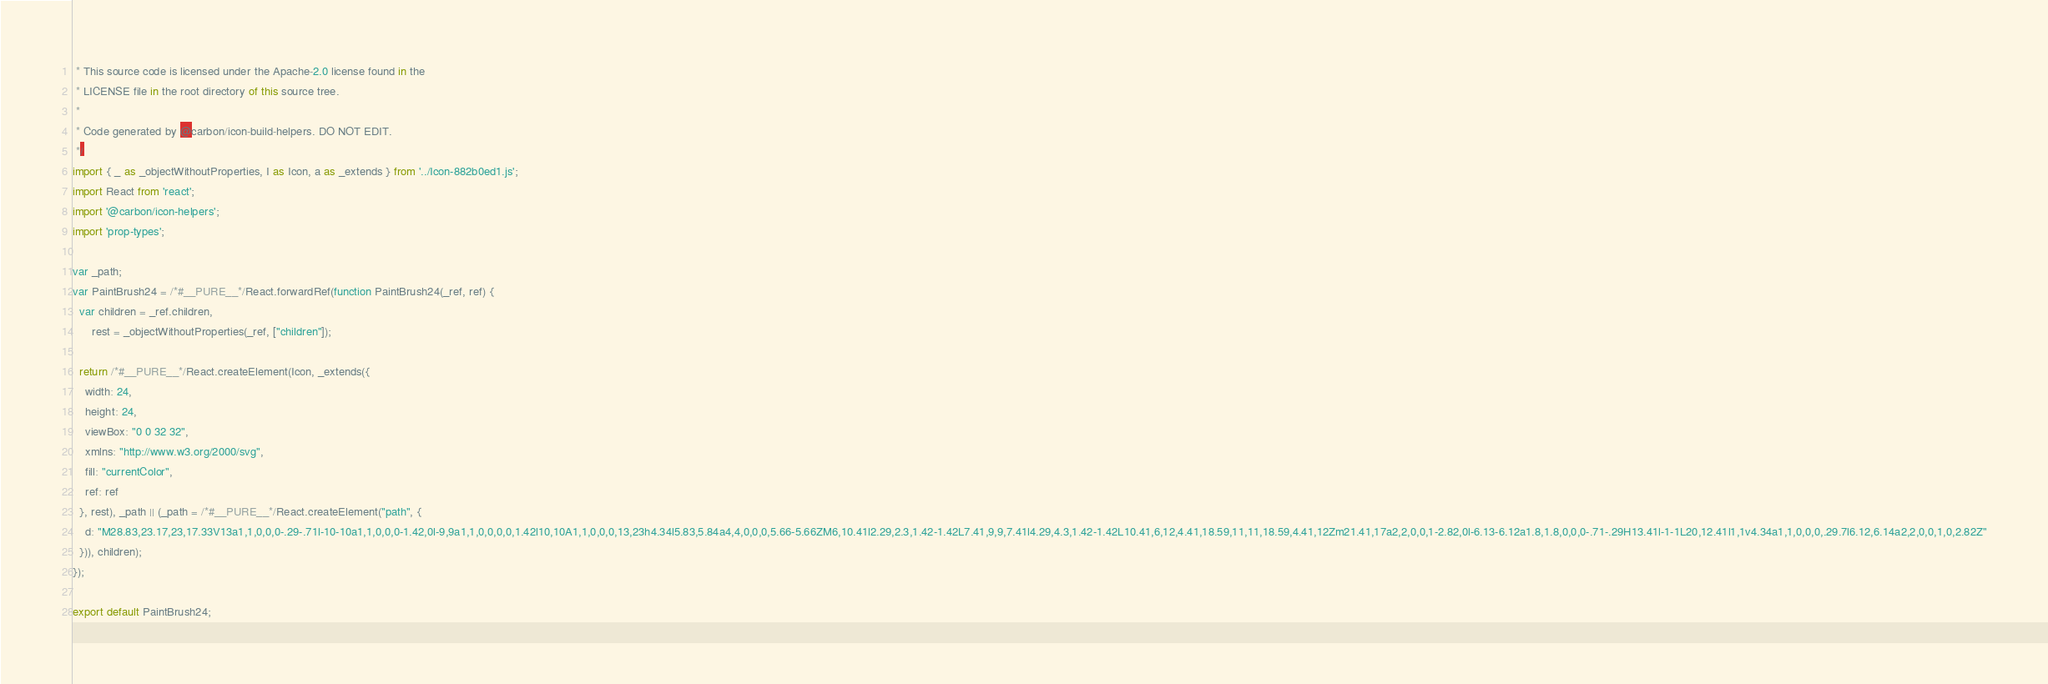Convert code to text. <code><loc_0><loc_0><loc_500><loc_500><_JavaScript_> * This source code is licensed under the Apache-2.0 license found in the
 * LICENSE file in the root directory of this source tree.
 *
 * Code generated by @carbon/icon-build-helpers. DO NOT EDIT.
 */
import { _ as _objectWithoutProperties, I as Icon, a as _extends } from '../Icon-882b0ed1.js';
import React from 'react';
import '@carbon/icon-helpers';
import 'prop-types';

var _path;
var PaintBrush24 = /*#__PURE__*/React.forwardRef(function PaintBrush24(_ref, ref) {
  var children = _ref.children,
      rest = _objectWithoutProperties(_ref, ["children"]);

  return /*#__PURE__*/React.createElement(Icon, _extends({
    width: 24,
    height: 24,
    viewBox: "0 0 32 32",
    xmlns: "http://www.w3.org/2000/svg",
    fill: "currentColor",
    ref: ref
  }, rest), _path || (_path = /*#__PURE__*/React.createElement("path", {
    d: "M28.83,23.17,23,17.33V13a1,1,0,0,0-.29-.71l-10-10a1,1,0,0,0-1.42,0l-9,9a1,1,0,0,0,0,1.42l10,10A1,1,0,0,0,13,23h4.34l5.83,5.84a4,4,0,0,0,5.66-5.66ZM6,10.41l2.29,2.3,1.42-1.42L7.41,9,9,7.41l4.29,4.3,1.42-1.42L10.41,6,12,4.41,18.59,11,11,18.59,4.41,12Zm21.41,17a2,2,0,0,1-2.82,0l-6.13-6.12a1.8,1.8,0,0,0-.71-.29H13.41l-1-1L20,12.41l1,1v4.34a1,1,0,0,0,.29.7l6.12,6.14a2,2,0,0,1,0,2.82Z"
  })), children);
});

export default PaintBrush24;
</code> 